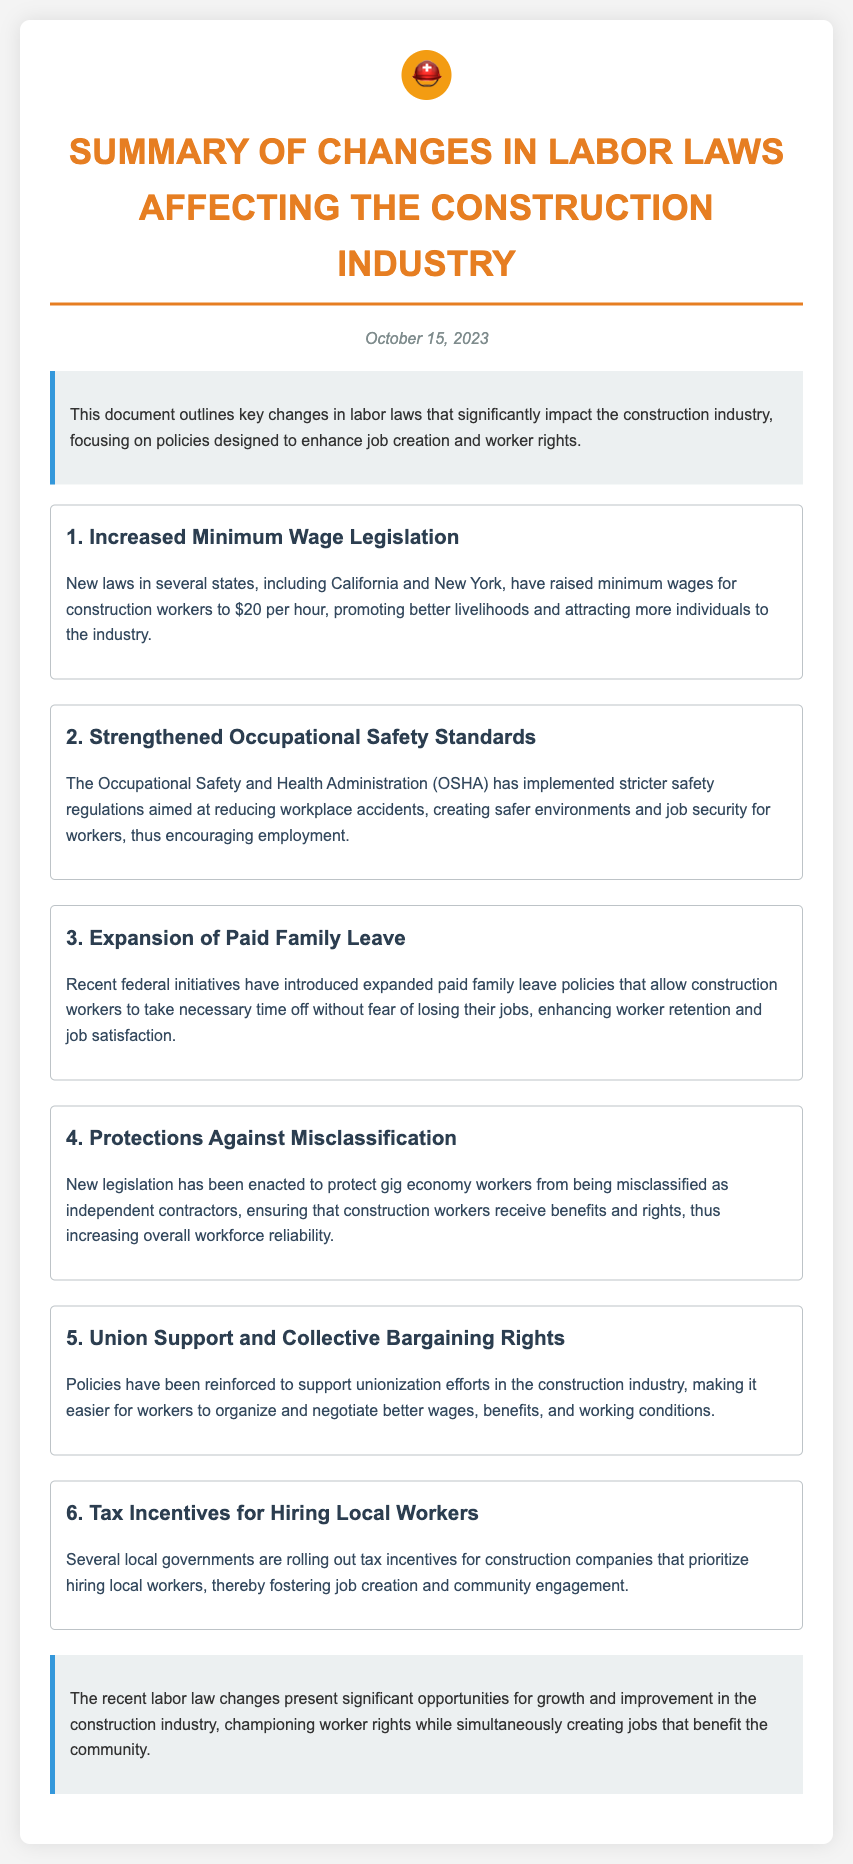What is the date of the document? The document states the date at the top, which is October 15, 2023.
Answer: October 15, 2023 What is the new minimum wage for construction workers? The document indicates that new laws have raised minimum wages for construction workers to $20 per hour.
Answer: $20 per hour Which organization implemented stricter safety regulations? The document mentions that the Occupational Safety and Health Administration (OSHA) has implemented the regulations.
Answer: OSHA What is the focus of the new paid family leave policies? The document describes that expanded paid family leave policies allow construction workers to take necessary time off without fear of losing their jobs.
Answer: Job security What is being reinforced to support workers in the construction industry? The document notes that policies have been reinforced to support unionization efforts, making it easier for workers to organize.
Answer: Unionization efforts How do local governments encourage job creation in construction? The document states that several local governments are rolling out tax incentives for construction companies that prioritize hiring local workers.
Answer: Tax incentives What is one benefit of strengthened occupational safety standards? The document explains that stricter safety regulations create safer environments for workers, which encourages employment.
Answer: Safer environments What issue does the new legislation address regarding gig economy workers? The document indicates that new legislation protects gig economy workers from being misclassified as independent contractors.
Answer: Misclassification How does the document conclude about the recent labor law changes? The conclusion outlines that the changes present significant opportunities for growth and improvement in the construction industry.
Answer: Growth and improvement 